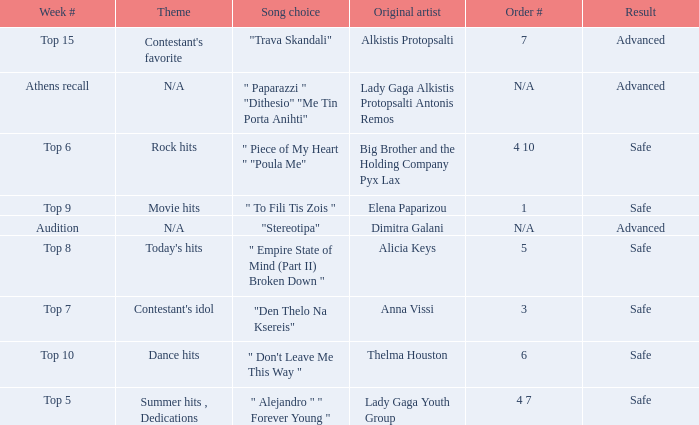Which artists have order number 6? Thelma Houston. 